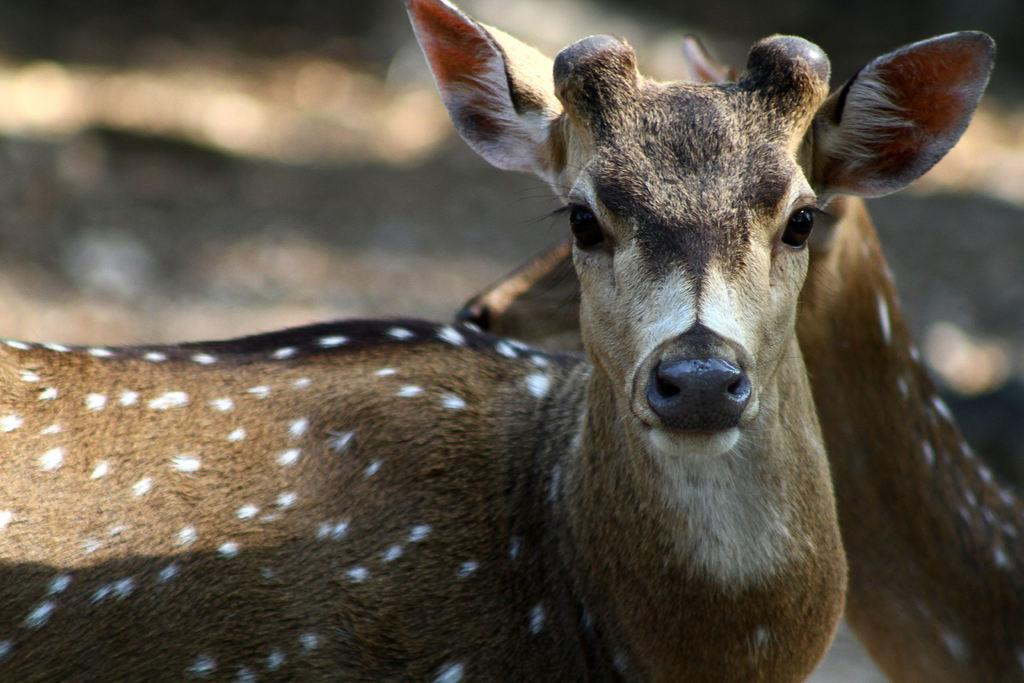What animal is the main subject of the image? There is a deer in the middle of the picture. Can you describe the background of the image? The background of the image is blurred. What type of advertisement can be seen in the background of the image? There is no advertisement present in the image. How many circles are visible in the image? There are no circles visible in the image. 